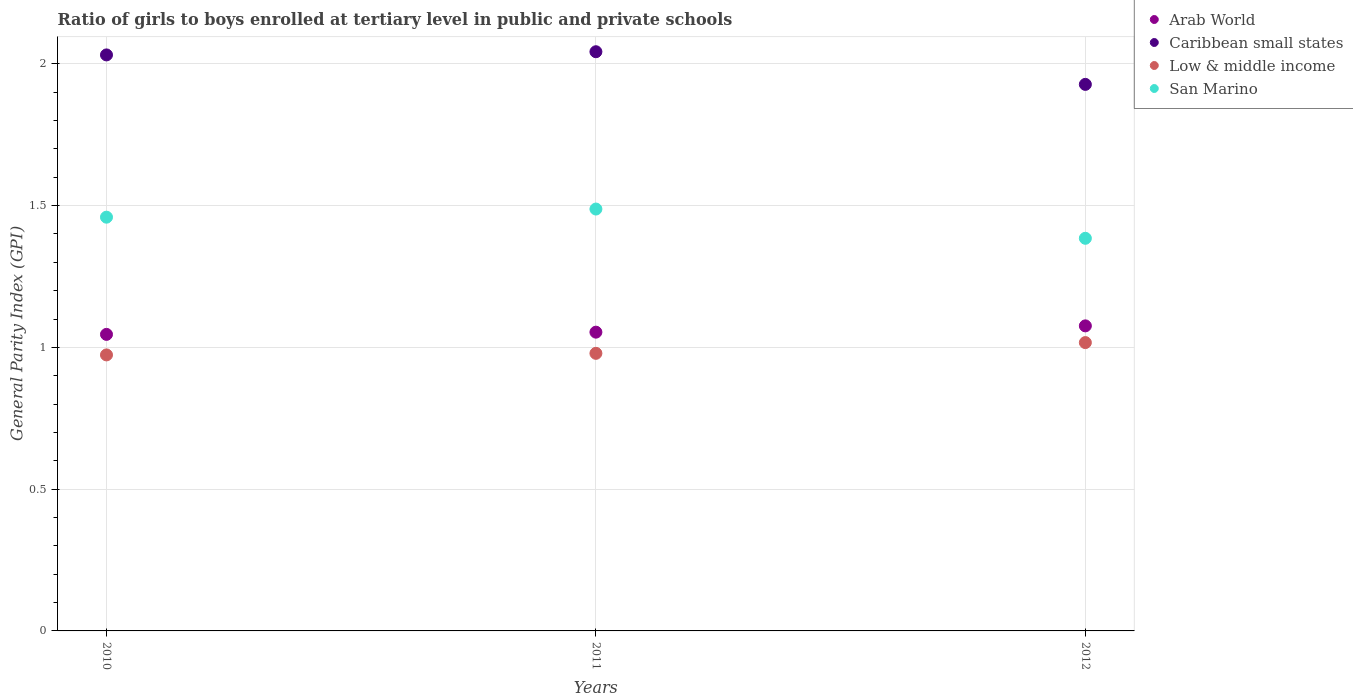How many different coloured dotlines are there?
Give a very brief answer. 4. Is the number of dotlines equal to the number of legend labels?
Keep it short and to the point. Yes. What is the general parity index in Arab World in 2012?
Your answer should be compact. 1.08. Across all years, what is the maximum general parity index in San Marino?
Offer a very short reply. 1.49. Across all years, what is the minimum general parity index in San Marino?
Your response must be concise. 1.38. What is the total general parity index in Low & middle income in the graph?
Provide a succinct answer. 2.97. What is the difference between the general parity index in Caribbean small states in 2011 and that in 2012?
Offer a terse response. 0.12. What is the difference between the general parity index in Arab World in 2011 and the general parity index in Caribbean small states in 2012?
Offer a terse response. -0.87. What is the average general parity index in Caribbean small states per year?
Your answer should be compact. 2. In the year 2012, what is the difference between the general parity index in San Marino and general parity index in Low & middle income?
Provide a succinct answer. 0.37. What is the ratio of the general parity index in Caribbean small states in 2010 to that in 2011?
Your answer should be very brief. 0.99. What is the difference between the highest and the second highest general parity index in San Marino?
Your response must be concise. 0.03. What is the difference between the highest and the lowest general parity index in San Marino?
Keep it short and to the point. 0.1. Is it the case that in every year, the sum of the general parity index in Low & middle income and general parity index in Arab World  is greater than the sum of general parity index in San Marino and general parity index in Caribbean small states?
Your response must be concise. Yes. Is it the case that in every year, the sum of the general parity index in Arab World and general parity index in San Marino  is greater than the general parity index in Caribbean small states?
Provide a succinct answer. Yes. Is the general parity index in Arab World strictly greater than the general parity index in San Marino over the years?
Your answer should be very brief. No. Is the general parity index in Arab World strictly less than the general parity index in San Marino over the years?
Offer a very short reply. Yes. How many dotlines are there?
Offer a terse response. 4. Are the values on the major ticks of Y-axis written in scientific E-notation?
Make the answer very short. No. Does the graph contain grids?
Give a very brief answer. Yes. Where does the legend appear in the graph?
Keep it short and to the point. Top right. How many legend labels are there?
Give a very brief answer. 4. What is the title of the graph?
Provide a succinct answer. Ratio of girls to boys enrolled at tertiary level in public and private schools. What is the label or title of the X-axis?
Your response must be concise. Years. What is the label or title of the Y-axis?
Make the answer very short. General Parity Index (GPI). What is the General Parity Index (GPI) of Arab World in 2010?
Offer a very short reply. 1.05. What is the General Parity Index (GPI) in Caribbean small states in 2010?
Your response must be concise. 2.03. What is the General Parity Index (GPI) in Low & middle income in 2010?
Offer a terse response. 0.97. What is the General Parity Index (GPI) in San Marino in 2010?
Your response must be concise. 1.46. What is the General Parity Index (GPI) in Arab World in 2011?
Offer a very short reply. 1.05. What is the General Parity Index (GPI) of Caribbean small states in 2011?
Make the answer very short. 2.04. What is the General Parity Index (GPI) of Low & middle income in 2011?
Your response must be concise. 0.98. What is the General Parity Index (GPI) in San Marino in 2011?
Give a very brief answer. 1.49. What is the General Parity Index (GPI) in Arab World in 2012?
Provide a succinct answer. 1.08. What is the General Parity Index (GPI) in Caribbean small states in 2012?
Your answer should be very brief. 1.93. What is the General Parity Index (GPI) in Low & middle income in 2012?
Ensure brevity in your answer.  1.02. What is the General Parity Index (GPI) in San Marino in 2012?
Keep it short and to the point. 1.38. Across all years, what is the maximum General Parity Index (GPI) in Arab World?
Give a very brief answer. 1.08. Across all years, what is the maximum General Parity Index (GPI) of Caribbean small states?
Provide a short and direct response. 2.04. Across all years, what is the maximum General Parity Index (GPI) in Low & middle income?
Keep it short and to the point. 1.02. Across all years, what is the maximum General Parity Index (GPI) of San Marino?
Your answer should be very brief. 1.49. Across all years, what is the minimum General Parity Index (GPI) of Arab World?
Offer a terse response. 1.05. Across all years, what is the minimum General Parity Index (GPI) in Caribbean small states?
Your response must be concise. 1.93. Across all years, what is the minimum General Parity Index (GPI) of Low & middle income?
Keep it short and to the point. 0.97. Across all years, what is the minimum General Parity Index (GPI) in San Marino?
Ensure brevity in your answer.  1.38. What is the total General Parity Index (GPI) in Arab World in the graph?
Your response must be concise. 3.18. What is the total General Parity Index (GPI) of Caribbean small states in the graph?
Your answer should be compact. 6. What is the total General Parity Index (GPI) in Low & middle income in the graph?
Make the answer very short. 2.97. What is the total General Parity Index (GPI) of San Marino in the graph?
Provide a succinct answer. 4.33. What is the difference between the General Parity Index (GPI) in Arab World in 2010 and that in 2011?
Ensure brevity in your answer.  -0.01. What is the difference between the General Parity Index (GPI) of Caribbean small states in 2010 and that in 2011?
Offer a terse response. -0.01. What is the difference between the General Parity Index (GPI) in Low & middle income in 2010 and that in 2011?
Your response must be concise. -0.01. What is the difference between the General Parity Index (GPI) in San Marino in 2010 and that in 2011?
Your response must be concise. -0.03. What is the difference between the General Parity Index (GPI) of Arab World in 2010 and that in 2012?
Give a very brief answer. -0.03. What is the difference between the General Parity Index (GPI) of Caribbean small states in 2010 and that in 2012?
Your response must be concise. 0.1. What is the difference between the General Parity Index (GPI) of Low & middle income in 2010 and that in 2012?
Your answer should be very brief. -0.04. What is the difference between the General Parity Index (GPI) of San Marino in 2010 and that in 2012?
Ensure brevity in your answer.  0.07. What is the difference between the General Parity Index (GPI) in Arab World in 2011 and that in 2012?
Your answer should be very brief. -0.02. What is the difference between the General Parity Index (GPI) of Caribbean small states in 2011 and that in 2012?
Offer a terse response. 0.12. What is the difference between the General Parity Index (GPI) in Low & middle income in 2011 and that in 2012?
Offer a very short reply. -0.04. What is the difference between the General Parity Index (GPI) of San Marino in 2011 and that in 2012?
Offer a terse response. 0.1. What is the difference between the General Parity Index (GPI) of Arab World in 2010 and the General Parity Index (GPI) of Caribbean small states in 2011?
Provide a short and direct response. -1. What is the difference between the General Parity Index (GPI) in Arab World in 2010 and the General Parity Index (GPI) in Low & middle income in 2011?
Offer a terse response. 0.07. What is the difference between the General Parity Index (GPI) of Arab World in 2010 and the General Parity Index (GPI) of San Marino in 2011?
Your answer should be compact. -0.44. What is the difference between the General Parity Index (GPI) in Caribbean small states in 2010 and the General Parity Index (GPI) in Low & middle income in 2011?
Your response must be concise. 1.05. What is the difference between the General Parity Index (GPI) of Caribbean small states in 2010 and the General Parity Index (GPI) of San Marino in 2011?
Your response must be concise. 0.54. What is the difference between the General Parity Index (GPI) in Low & middle income in 2010 and the General Parity Index (GPI) in San Marino in 2011?
Provide a short and direct response. -0.51. What is the difference between the General Parity Index (GPI) in Arab World in 2010 and the General Parity Index (GPI) in Caribbean small states in 2012?
Give a very brief answer. -0.88. What is the difference between the General Parity Index (GPI) in Arab World in 2010 and the General Parity Index (GPI) in Low & middle income in 2012?
Give a very brief answer. 0.03. What is the difference between the General Parity Index (GPI) of Arab World in 2010 and the General Parity Index (GPI) of San Marino in 2012?
Give a very brief answer. -0.34. What is the difference between the General Parity Index (GPI) of Caribbean small states in 2010 and the General Parity Index (GPI) of Low & middle income in 2012?
Your answer should be compact. 1.01. What is the difference between the General Parity Index (GPI) in Caribbean small states in 2010 and the General Parity Index (GPI) in San Marino in 2012?
Offer a terse response. 0.65. What is the difference between the General Parity Index (GPI) of Low & middle income in 2010 and the General Parity Index (GPI) of San Marino in 2012?
Offer a very short reply. -0.41. What is the difference between the General Parity Index (GPI) in Arab World in 2011 and the General Parity Index (GPI) in Caribbean small states in 2012?
Offer a very short reply. -0.87. What is the difference between the General Parity Index (GPI) of Arab World in 2011 and the General Parity Index (GPI) of Low & middle income in 2012?
Your answer should be very brief. 0.04. What is the difference between the General Parity Index (GPI) of Arab World in 2011 and the General Parity Index (GPI) of San Marino in 2012?
Your answer should be very brief. -0.33. What is the difference between the General Parity Index (GPI) of Caribbean small states in 2011 and the General Parity Index (GPI) of Low & middle income in 2012?
Provide a succinct answer. 1.03. What is the difference between the General Parity Index (GPI) of Caribbean small states in 2011 and the General Parity Index (GPI) of San Marino in 2012?
Your response must be concise. 0.66. What is the difference between the General Parity Index (GPI) in Low & middle income in 2011 and the General Parity Index (GPI) in San Marino in 2012?
Offer a terse response. -0.41. What is the average General Parity Index (GPI) in Arab World per year?
Your response must be concise. 1.06. What is the average General Parity Index (GPI) in Caribbean small states per year?
Offer a terse response. 2. What is the average General Parity Index (GPI) in Low & middle income per year?
Keep it short and to the point. 0.99. What is the average General Parity Index (GPI) of San Marino per year?
Keep it short and to the point. 1.44. In the year 2010, what is the difference between the General Parity Index (GPI) in Arab World and General Parity Index (GPI) in Caribbean small states?
Keep it short and to the point. -0.99. In the year 2010, what is the difference between the General Parity Index (GPI) of Arab World and General Parity Index (GPI) of Low & middle income?
Your answer should be very brief. 0.07. In the year 2010, what is the difference between the General Parity Index (GPI) in Arab World and General Parity Index (GPI) in San Marino?
Your response must be concise. -0.41. In the year 2010, what is the difference between the General Parity Index (GPI) of Caribbean small states and General Parity Index (GPI) of Low & middle income?
Offer a very short reply. 1.06. In the year 2010, what is the difference between the General Parity Index (GPI) in Caribbean small states and General Parity Index (GPI) in San Marino?
Give a very brief answer. 0.57. In the year 2010, what is the difference between the General Parity Index (GPI) in Low & middle income and General Parity Index (GPI) in San Marino?
Make the answer very short. -0.49. In the year 2011, what is the difference between the General Parity Index (GPI) in Arab World and General Parity Index (GPI) in Caribbean small states?
Make the answer very short. -0.99. In the year 2011, what is the difference between the General Parity Index (GPI) of Arab World and General Parity Index (GPI) of Low & middle income?
Provide a succinct answer. 0.07. In the year 2011, what is the difference between the General Parity Index (GPI) of Arab World and General Parity Index (GPI) of San Marino?
Make the answer very short. -0.43. In the year 2011, what is the difference between the General Parity Index (GPI) of Caribbean small states and General Parity Index (GPI) of Low & middle income?
Your answer should be very brief. 1.06. In the year 2011, what is the difference between the General Parity Index (GPI) in Caribbean small states and General Parity Index (GPI) in San Marino?
Ensure brevity in your answer.  0.55. In the year 2011, what is the difference between the General Parity Index (GPI) of Low & middle income and General Parity Index (GPI) of San Marino?
Provide a short and direct response. -0.51. In the year 2012, what is the difference between the General Parity Index (GPI) in Arab World and General Parity Index (GPI) in Caribbean small states?
Offer a very short reply. -0.85. In the year 2012, what is the difference between the General Parity Index (GPI) of Arab World and General Parity Index (GPI) of Low & middle income?
Give a very brief answer. 0.06. In the year 2012, what is the difference between the General Parity Index (GPI) in Arab World and General Parity Index (GPI) in San Marino?
Ensure brevity in your answer.  -0.31. In the year 2012, what is the difference between the General Parity Index (GPI) in Caribbean small states and General Parity Index (GPI) in Low & middle income?
Offer a terse response. 0.91. In the year 2012, what is the difference between the General Parity Index (GPI) in Caribbean small states and General Parity Index (GPI) in San Marino?
Ensure brevity in your answer.  0.54. In the year 2012, what is the difference between the General Parity Index (GPI) of Low & middle income and General Parity Index (GPI) of San Marino?
Your answer should be compact. -0.37. What is the ratio of the General Parity Index (GPI) of Caribbean small states in 2010 to that in 2011?
Offer a very short reply. 0.99. What is the ratio of the General Parity Index (GPI) of Low & middle income in 2010 to that in 2011?
Your response must be concise. 0.99. What is the ratio of the General Parity Index (GPI) of San Marino in 2010 to that in 2011?
Give a very brief answer. 0.98. What is the ratio of the General Parity Index (GPI) in Arab World in 2010 to that in 2012?
Make the answer very short. 0.97. What is the ratio of the General Parity Index (GPI) in Caribbean small states in 2010 to that in 2012?
Offer a terse response. 1.05. What is the ratio of the General Parity Index (GPI) of Low & middle income in 2010 to that in 2012?
Ensure brevity in your answer.  0.96. What is the ratio of the General Parity Index (GPI) of San Marino in 2010 to that in 2012?
Your answer should be compact. 1.05. What is the ratio of the General Parity Index (GPI) of Arab World in 2011 to that in 2012?
Your answer should be very brief. 0.98. What is the ratio of the General Parity Index (GPI) in Caribbean small states in 2011 to that in 2012?
Your answer should be very brief. 1.06. What is the ratio of the General Parity Index (GPI) in Low & middle income in 2011 to that in 2012?
Provide a short and direct response. 0.96. What is the ratio of the General Parity Index (GPI) of San Marino in 2011 to that in 2012?
Provide a succinct answer. 1.07. What is the difference between the highest and the second highest General Parity Index (GPI) of Arab World?
Your answer should be very brief. 0.02. What is the difference between the highest and the second highest General Parity Index (GPI) in Caribbean small states?
Offer a terse response. 0.01. What is the difference between the highest and the second highest General Parity Index (GPI) of Low & middle income?
Your answer should be very brief. 0.04. What is the difference between the highest and the second highest General Parity Index (GPI) in San Marino?
Your answer should be compact. 0.03. What is the difference between the highest and the lowest General Parity Index (GPI) in Arab World?
Offer a terse response. 0.03. What is the difference between the highest and the lowest General Parity Index (GPI) in Caribbean small states?
Provide a short and direct response. 0.12. What is the difference between the highest and the lowest General Parity Index (GPI) in Low & middle income?
Make the answer very short. 0.04. What is the difference between the highest and the lowest General Parity Index (GPI) of San Marino?
Your response must be concise. 0.1. 